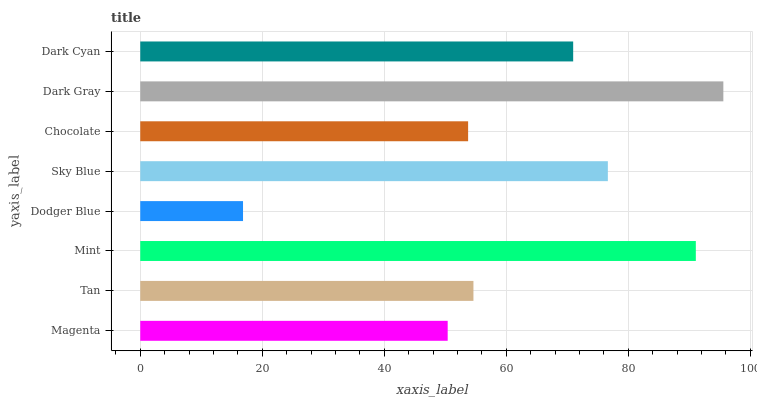Is Dodger Blue the minimum?
Answer yes or no. Yes. Is Dark Gray the maximum?
Answer yes or no. Yes. Is Tan the minimum?
Answer yes or no. No. Is Tan the maximum?
Answer yes or no. No. Is Tan greater than Magenta?
Answer yes or no. Yes. Is Magenta less than Tan?
Answer yes or no. Yes. Is Magenta greater than Tan?
Answer yes or no. No. Is Tan less than Magenta?
Answer yes or no. No. Is Dark Cyan the high median?
Answer yes or no. Yes. Is Tan the low median?
Answer yes or no. Yes. Is Mint the high median?
Answer yes or no. No. Is Sky Blue the low median?
Answer yes or no. No. 